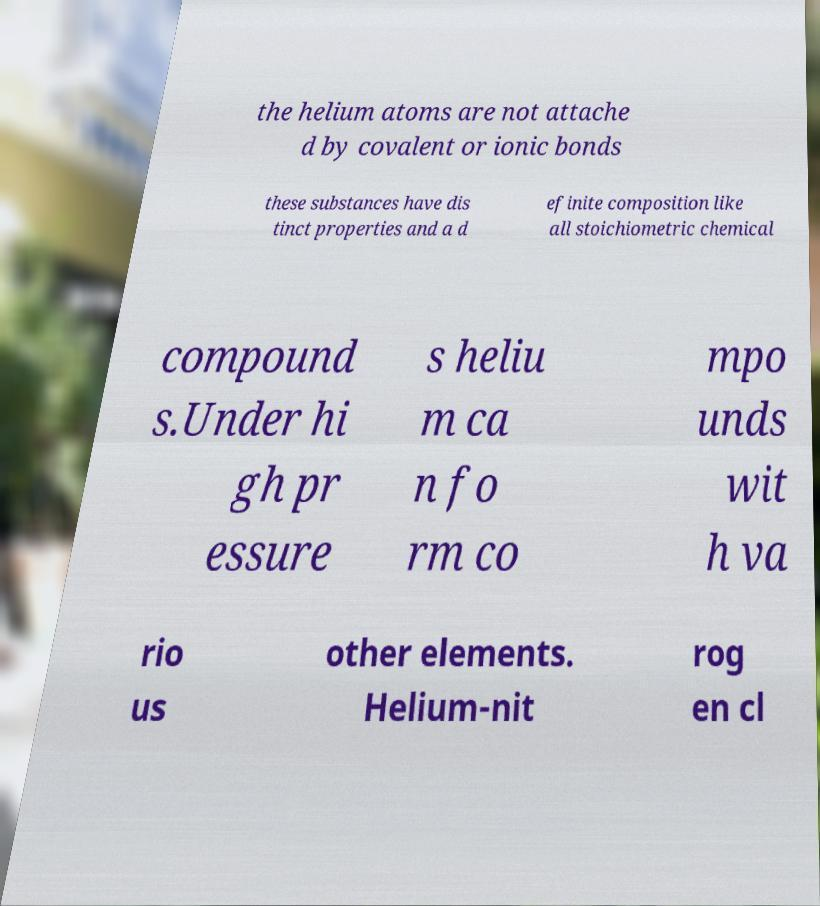Could you assist in decoding the text presented in this image and type it out clearly? the helium atoms are not attache d by covalent or ionic bonds these substances have dis tinct properties and a d efinite composition like all stoichiometric chemical compound s.Under hi gh pr essure s heliu m ca n fo rm co mpo unds wit h va rio us other elements. Helium-nit rog en cl 